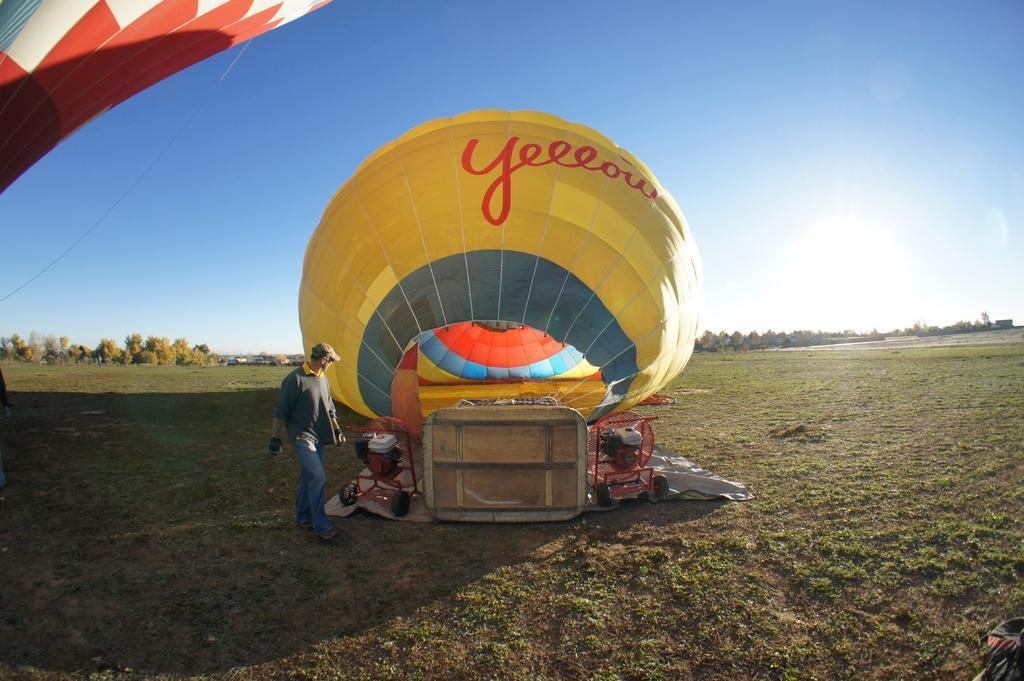Could you give a brief overview of what you see in this image? In this image, we can see parachutes, few machines and some objects. Here we can see a person is walking on the ground. Background we can see so many trees and sky. 